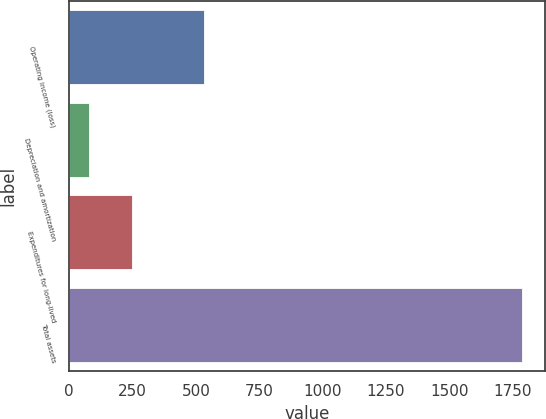Convert chart to OTSL. <chart><loc_0><loc_0><loc_500><loc_500><bar_chart><fcel>Operating income (loss)<fcel>Depreciation and amortization<fcel>Expenditures for long-lived<fcel>Total assets<nl><fcel>530.2<fcel>77.4<fcel>248.36<fcel>1787<nl></chart> 